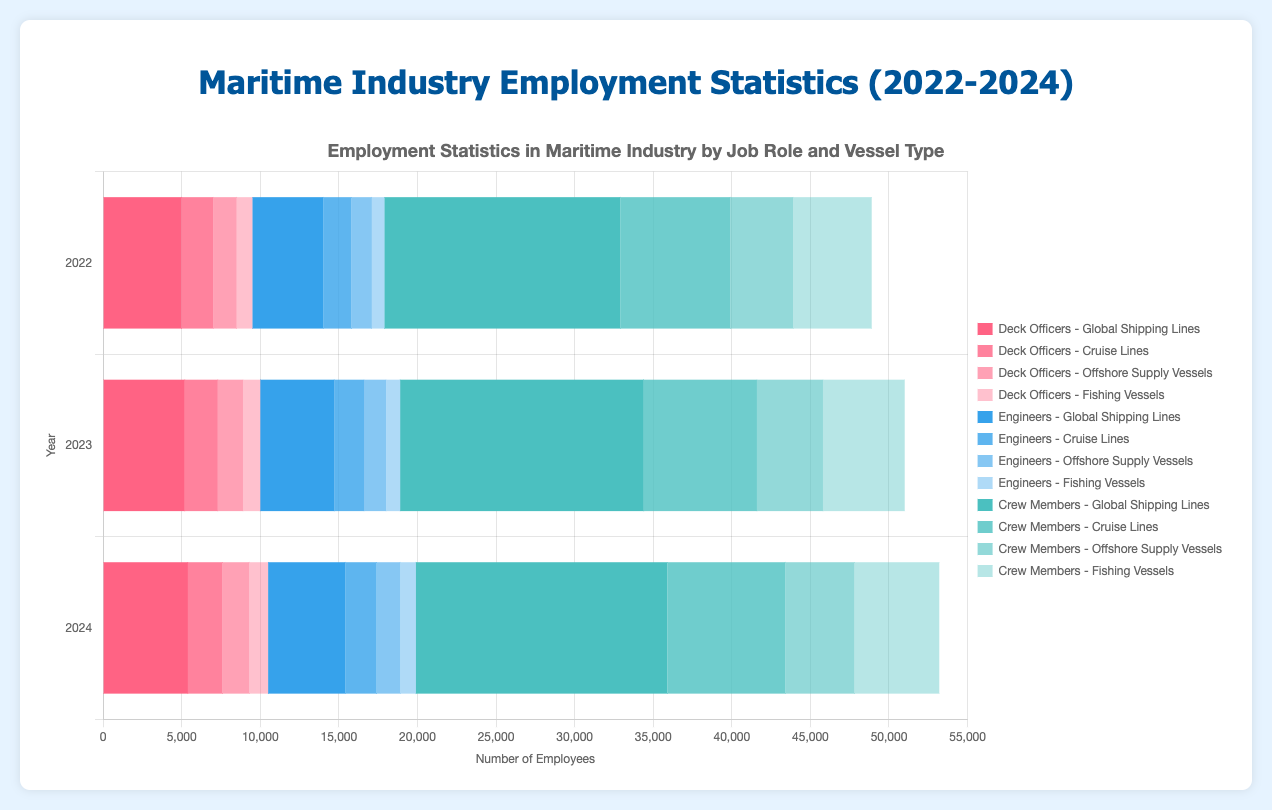What is the total number of Deck Officers in 2023 across all vessel types? First, find the number of Deck Officers for each vessel type in 2023: Global Shipping Lines (5200), Cruise Lines (2100), Offshore Supply Vessels (1600), and Fishing Vessels (1100). Then, sum them: 5200 + 2100 + 1600 + 1100 = 10000.
Answer: 10000 Which year had the highest number of Crew Members in Global Shipping Lines? Compare the number of Crew Members in Global Shipping Lines for each year: 2022 (15000), 2023 (15500), and 2024 (16000). The highest number is in 2024.
Answer: 2024 What are the trends in employment for Engineers in Offshore Supply Vessels from 2022 to 2024? Look at the numbers for Engineers in Offshore Supply Vessels for each year: 2022 (1300), 2023 (1400), and 2024 (1500). The numbers increase each year, indicating an upward trend.
Answer: Upward trend How does the number of Crew Members in Fishing Vessels in 2022 compare to 2024? Compare the number of Crew Members in Fishing Vessels for 2022 (5000) and 2024 (5400). The number in 2024 is higher by 400.
Answer: Higher in 2024 by 400 Which vessel type had the least number of Deck Officers in 2024? Compare the number of Deck Officers for each vessel type in 2024: Global Shipping Lines (5400), Cruise Lines (2200), Offshore Supply Vessels (1700), and Fishing Vessels (1200). The least number is for Fishing Vessels.
Answer: Fishing Vessels What is the difference in the number of Engineers between Cruise Lines and Offshore Supply Vessels in 2023? Find the number of Engineers for Cruise Lines (1900) and Offshore Supply Vessels (1400) in 2023, and then calculate the difference: 1900 - 1400 = 500.
Answer: 500 How did the total employment numbers for Crew Members in Global Shipping Lines change from 2022 to 2024? Compare the number of Crew Members in Global Shipping Lines for 2022 (15000) and 2024 (16000). The increase is 16000 - 15000 = 1000.
Answer: Increased by 1000 Which job role had a consistent increase in employment numbers across all vessel types from 2022 to 2024? Check the employment numbers for Deck Officers, Engineers, and Crew Members across all vessel types from 2022 to 2024. Only Engineers show an increase for Global Shipping Lines, Cruise Lines, Offshore Supply Vessels, and Fishing Vessels each year.
Answer: Engineers 